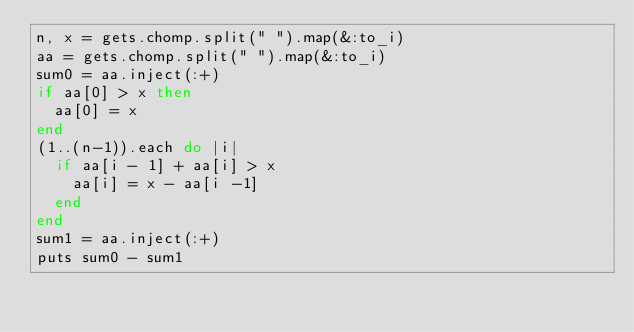Convert code to text. <code><loc_0><loc_0><loc_500><loc_500><_Ruby_>n, x = gets.chomp.split(" ").map(&:to_i)
aa = gets.chomp.split(" ").map(&:to_i)
sum0 = aa.inject(:+)
if aa[0] > x then
  aa[0] = x
end
(1..(n-1)).each do |i|
  if aa[i - 1] + aa[i] > x
    aa[i] = x - aa[i -1]
  end
end
sum1 = aa.inject(:+)
puts sum0 - sum1</code> 